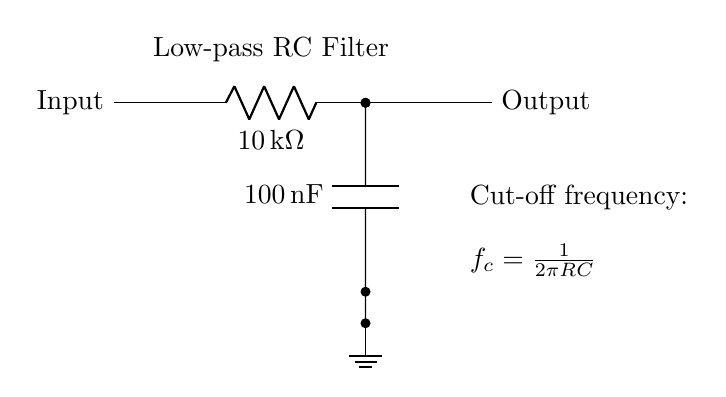What type of filter is represented in this circuit? The circuit is designed as a low-pass filter, which allows low frequencies to pass through while attenuating higher frequencies. This is indicated by the labeling in the diagram and the arrangement of the resistor and capacitor.
Answer: Low-pass filter What is the value of the resistor in this circuit? The resistor value is shown in the diagram as 10 kOhm, which is explicitly labeled next to the resistor symbol in the circuit.
Answer: 10 kOhm What is the value of the capacitor in this circuit? The capacitor value is listed as 100 nF (nanofarads). This is clearly indicated alongside the capacitor symbol in the diagram.
Answer: 100 nF What is the formula for the cut-off frequency provided in the diagram? The cut-off frequency formula is stated in the diagram as f_c = 1/(2πRC). This formula allows us to calculate the frequency at which the output voltage drops to 70.7% of the input voltage.
Answer: f_c = 1/(2πRC) What happens to higher frequencies as they pass through this circuit? Higher frequencies are attenuated when they pass through the low-pass RC filter, meaning their amplitude is reduced. This is a fundamental characteristic of low-pass filters, which selectively allow lower frequencies to reach the output.
Answer: Attenuated Which components work together to filter noise in this circuit? The combination of the resistor and capacitor works together to create the low-pass filter effect, with the resistor determining the flow of current and the capacitor affecting the timing of voltage changes.
Answer: Resistor and capacitor 